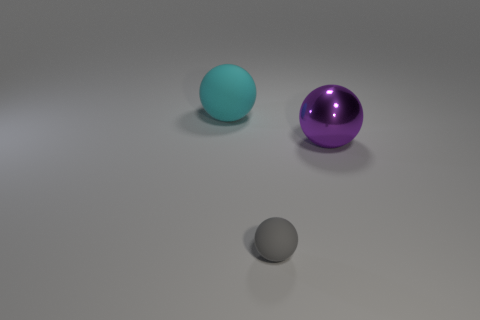Add 1 small gray metal objects. How many objects exist? 4 Subtract 0 green cubes. How many objects are left? 3 Subtract all small gray metallic cubes. Subtract all spheres. How many objects are left? 0 Add 1 big cyan rubber spheres. How many big cyan rubber spheres are left? 2 Add 2 large brown balls. How many large brown balls exist? 2 